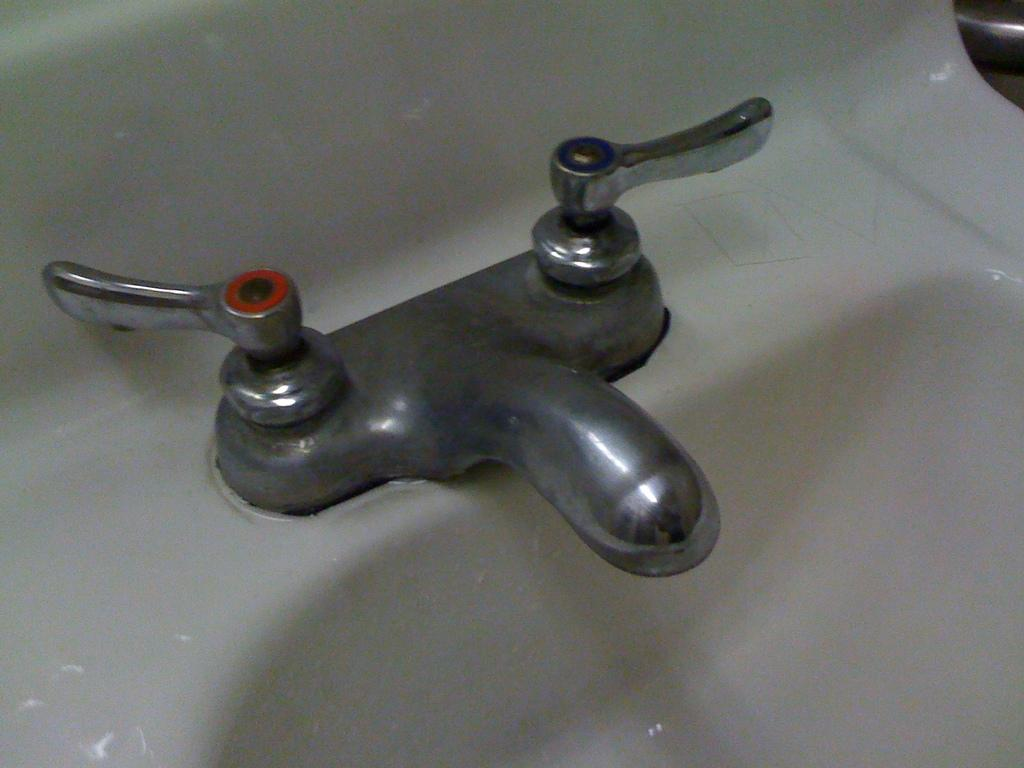What can be found in the image that is used for washing or cleaning? There is a sink with taps in the image, which can be used for washing or cleaning. What is the color or material of the object on the right side of the image? The object on the right side of the image is silver-colored. How many silk scarves are draped over the silver-colored object in the image? There are no silk scarves present in the image. Can you see a ladybug crawling on the sink in the image? There is no ladybug visible in the image. 